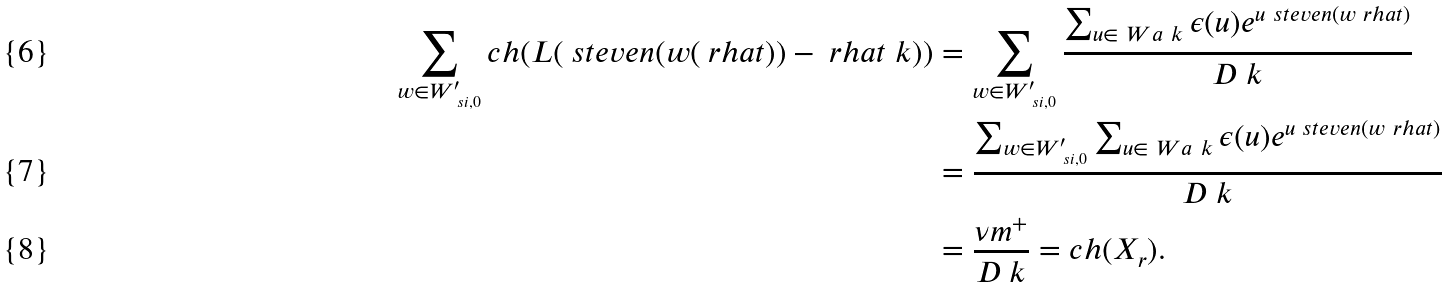<formula> <loc_0><loc_0><loc_500><loc_500>\sum _ { w \in W ^ { \prime } _ { \ s i , 0 } } c h ( L ( \ s t e v e n ( w ( \ r h a t ) ) - \ r h a t _ { \ } k ) ) & = \sum _ { w \in W ^ { \prime } _ { \ s i , 0 } } \frac { \sum _ { u \in \ W a _ { \ } k } \epsilon ( u ) e ^ { u \ s t e v e n ( w \ r h a t ) } } { D _ { \ } k } \\ & = \frac { \sum _ { w \in W ^ { \prime } _ { \ s i , 0 } } \sum _ { u \in \ W a _ { \ } k } \epsilon ( u ) e ^ { u \ s t e v e n ( w \ r h a t ) } } { D _ { \ } k } \\ & = \frac { \nu m ^ { + } } { D _ { \ } k } = c h ( X _ { r } ) .</formula> 